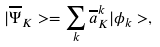<formula> <loc_0><loc_0><loc_500><loc_500>| \overline { \Psi } _ { K } > = \sum _ { k } \overline { a } ^ { k } _ { K } | \phi _ { k } > ,</formula> 